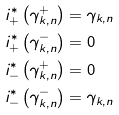Convert formula to latex. <formula><loc_0><loc_0><loc_500><loc_500>i _ { + } ^ { * } \left ( \gamma _ { k , n } ^ { + } \right ) & = \gamma _ { k , n } \\ i _ { + } ^ { * } \left ( \gamma _ { k , n } ^ { - } \right ) & = 0 \\ i _ { - } ^ { * } \left ( \gamma _ { k , n } ^ { + } \right ) & = 0 \\ i _ { - } ^ { * } \left ( \gamma _ { k , n } ^ { - } \right ) & = \gamma _ { k , n } \\</formula> 